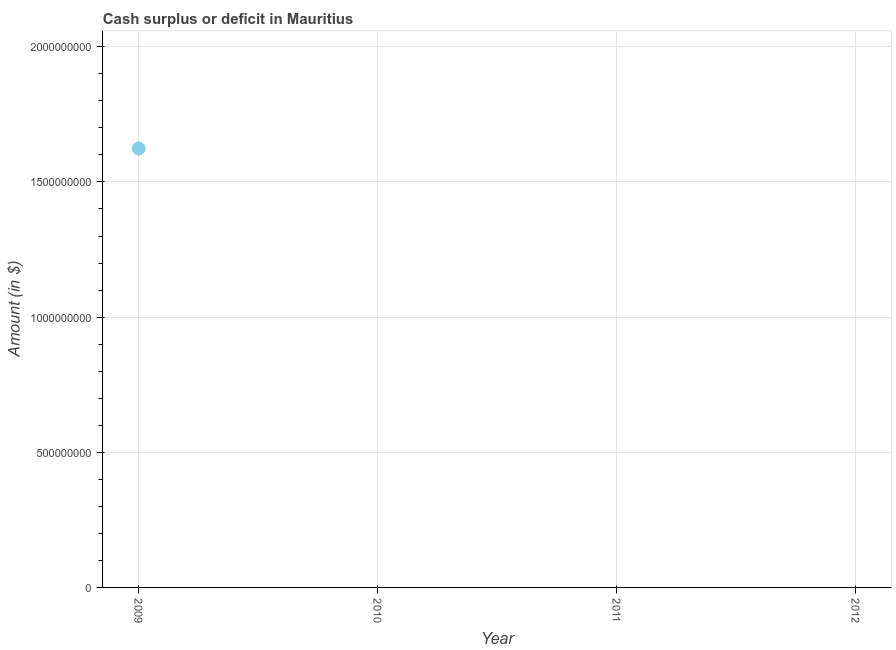Across all years, what is the maximum cash surplus or deficit?
Your answer should be very brief. 1.62e+09. In which year was the cash surplus or deficit maximum?
Your response must be concise. 2009. What is the sum of the cash surplus or deficit?
Provide a short and direct response. 1.62e+09. What is the average cash surplus or deficit per year?
Keep it short and to the point. 4.06e+08. What is the median cash surplus or deficit?
Provide a short and direct response. 0. In how many years, is the cash surplus or deficit greater than 1600000000 $?
Offer a very short reply. 1. What is the difference between the highest and the lowest cash surplus or deficit?
Ensure brevity in your answer.  1.62e+09. In how many years, is the cash surplus or deficit greater than the average cash surplus or deficit taken over all years?
Your answer should be compact. 1. Does the cash surplus or deficit monotonically increase over the years?
Your response must be concise. No. How many years are there in the graph?
Your response must be concise. 4. What is the difference between two consecutive major ticks on the Y-axis?
Provide a short and direct response. 5.00e+08. Are the values on the major ticks of Y-axis written in scientific E-notation?
Make the answer very short. No. Does the graph contain any zero values?
Offer a very short reply. Yes. What is the title of the graph?
Provide a short and direct response. Cash surplus or deficit in Mauritius. What is the label or title of the Y-axis?
Provide a succinct answer. Amount (in $). What is the Amount (in $) in 2009?
Give a very brief answer. 1.62e+09. What is the Amount (in $) in 2011?
Provide a succinct answer. 0. 